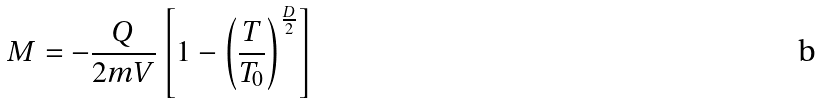Convert formula to latex. <formula><loc_0><loc_0><loc_500><loc_500>M = - \frac { Q } { 2 m V } \left [ 1 - \left ( \frac { T } { T _ { 0 } } \right ) ^ { \frac { D } { 2 } } \right ]</formula> 